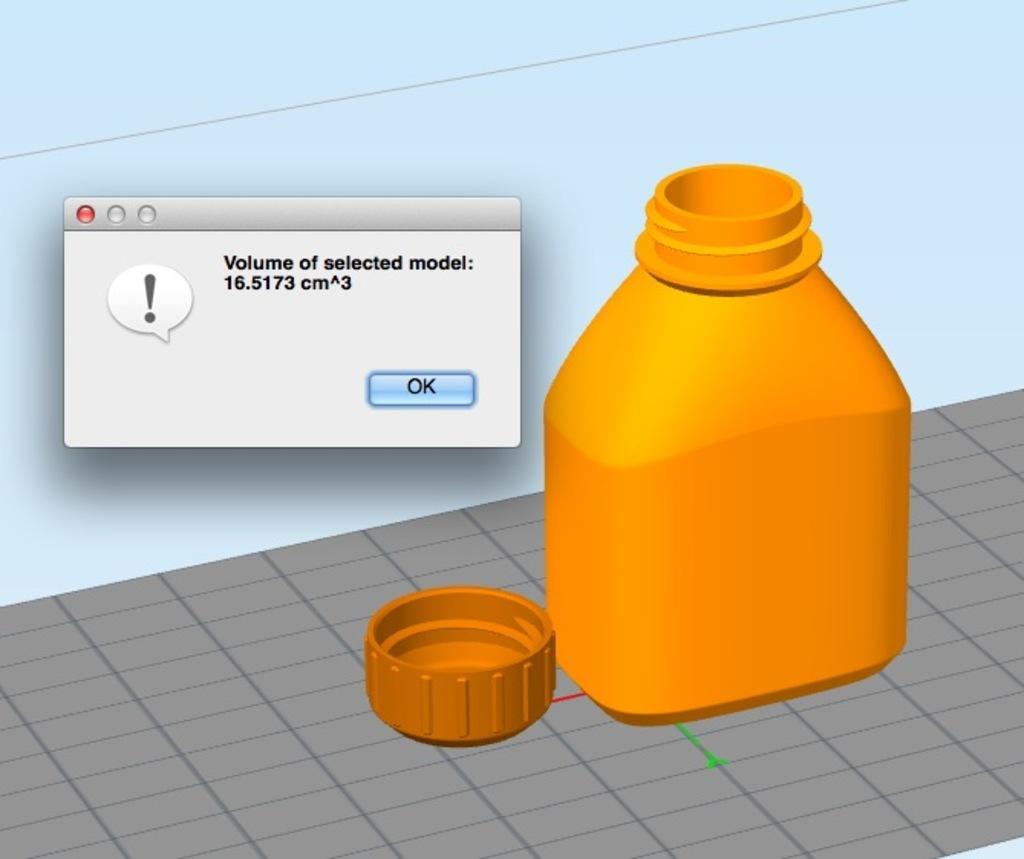Describe this image in one or two sentences. This is an edited image. In the image there is a bottle and a cap of bottle on the floor. There is a pop-up box with a text and a button. 